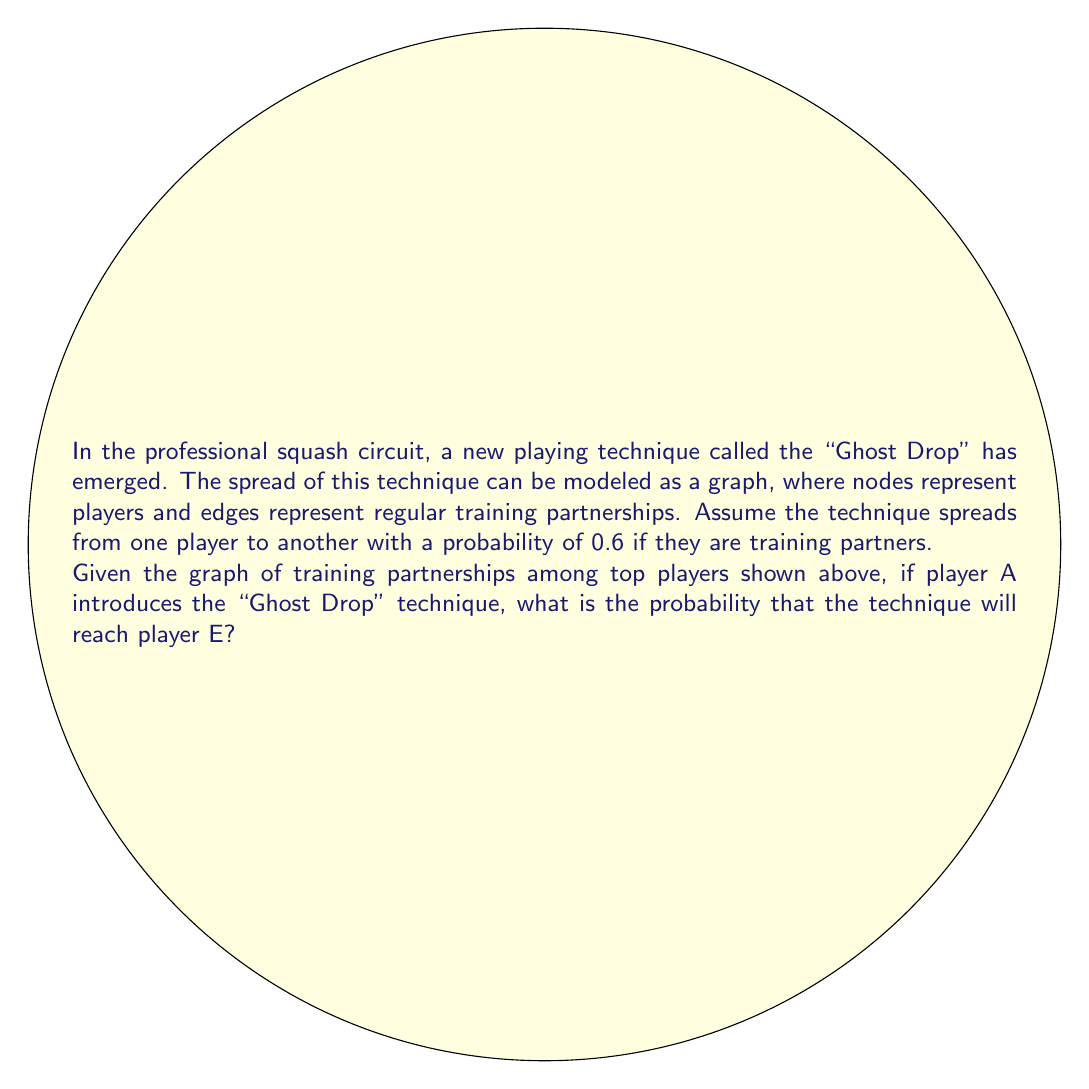Help me with this question. To solve this problem, we need to consider all possible paths from player A to player E and calculate the probability of the technique spreading along each path. Then, we'll combine these probabilities to find the overall probability of the technique reaching E.

Step 1: Identify all paths from A to E
1. A → B → D → E
2. A → B → E
3. A → C → D → E

Step 2: Calculate the probability for each path
1. P(A → B → D → E) = 0.6 × 0.6 × 0.6 = 0.216
2. P(A → B → E) = 0.6 × 0.6 = 0.36
3. P(A → C → D → E) = 0.6 × 0.6 × 0.6 = 0.216

Step 3: Calculate the probability that the technique doesn't spread through each path
1. P(not A → B → D → E) = 1 - 0.216 = 0.784
2. P(not A → B → E) = 1 - 0.36 = 0.64
3. P(not A → C → D → E) = 1 - 0.216 = 0.784

Step 4: Calculate the probability that the technique doesn't spread through any path
P(technique doesn't reach E) = 0.784 × 0.64 × 0.784 = 0.3936

Step 5: Calculate the probability that the technique reaches E
P(technique reaches E) = 1 - P(technique doesn't reach E)
                       = 1 - 0.3936
                       = 0.6064

Therefore, the probability that the "Ghost Drop" technique will reach player E is approximately 0.6064 or 60.64%.
Answer: 0.6064 